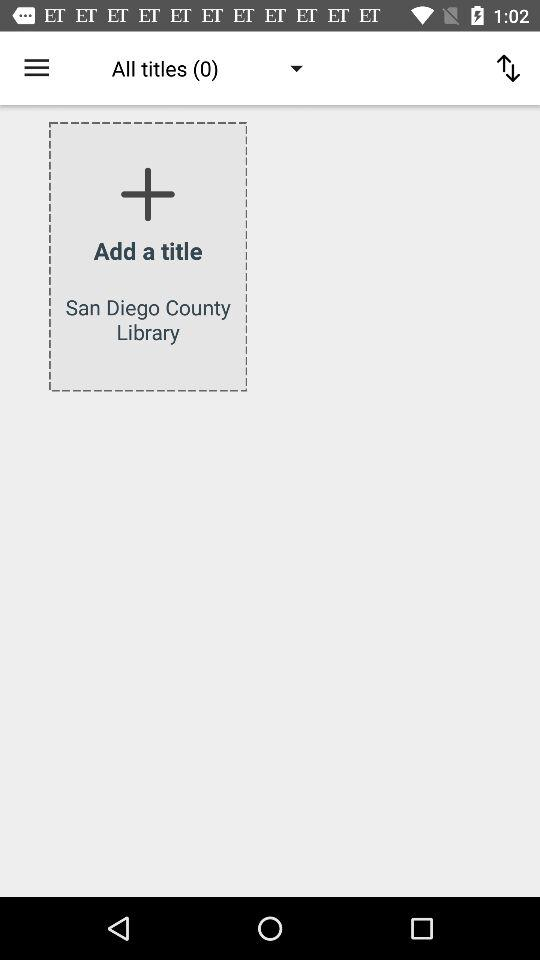What is the mentioned number of all titles? The mentioned number of all titles is 0. 